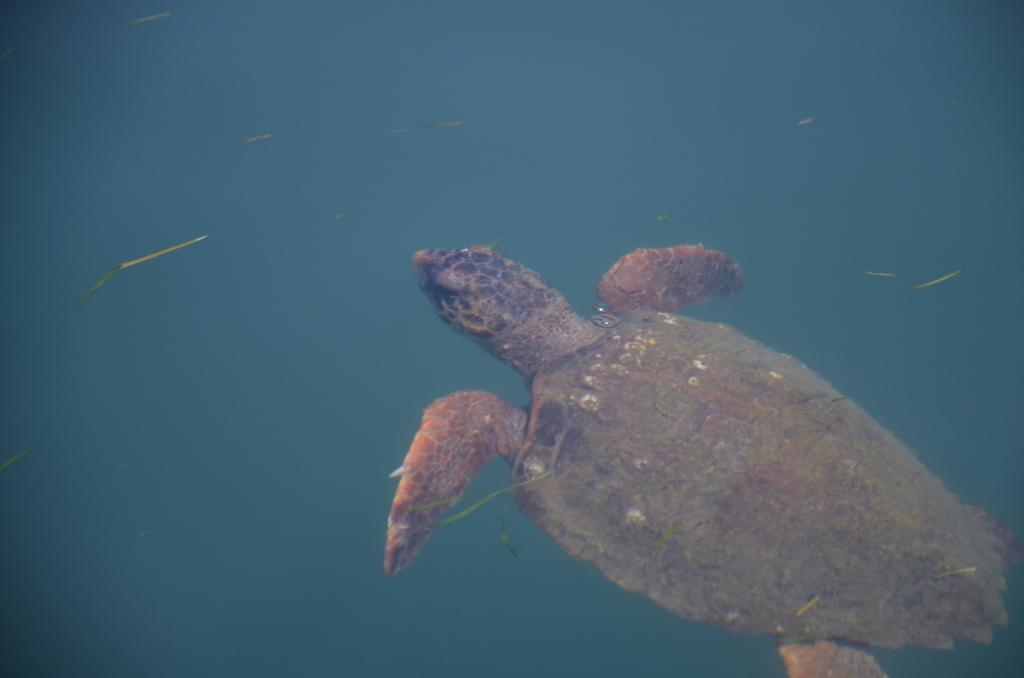What type of animal is in the image? There is a tortoise in the image. Can you describe the environment in which the tortoise is located? The tortoise is in the water in the image. What else can be seen in the water in the image? There are unspecified objects in the water in the image. What type of trucks can be seen driving next to the tortoise in the image? There are no trucks present in the image; it features a tortoise in the water with unspecified objects. What direction is the scarecrow facing in the image? There is no scarecrow present in the image. 